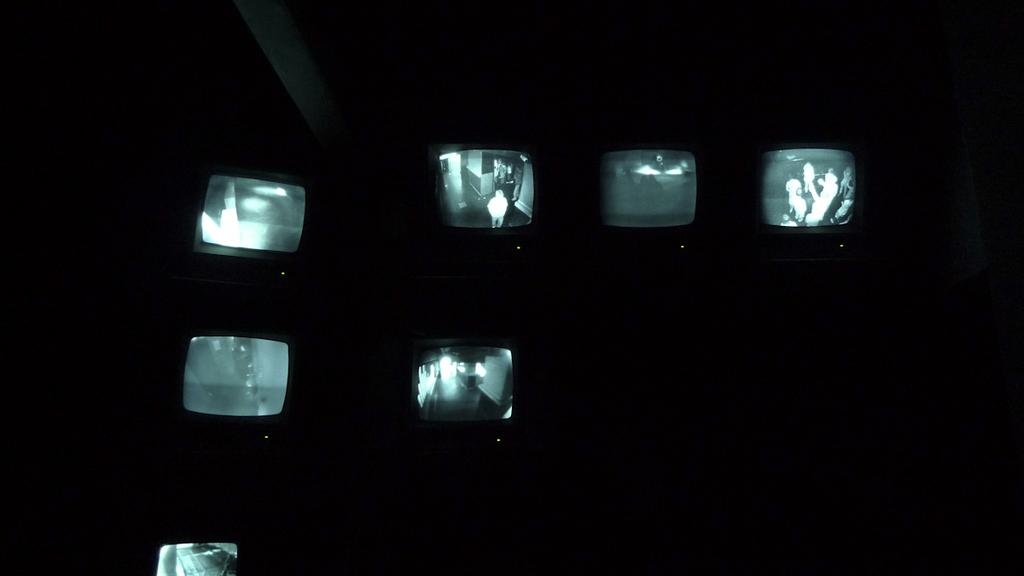What is the main subject of the image? The main subject of the image is television screens. How would you describe the overall appearance of the image? The image has a dark view. Can you describe what is displayed on some of the screens? On some screens, there are people visible. What type of guide is present on the television screens in the image? There is no guide present on the television screens in the image. What is the condition of the angle of the television screens in the image? The angle of the television screens is not mentioned in the image, so it cannot be determined. 